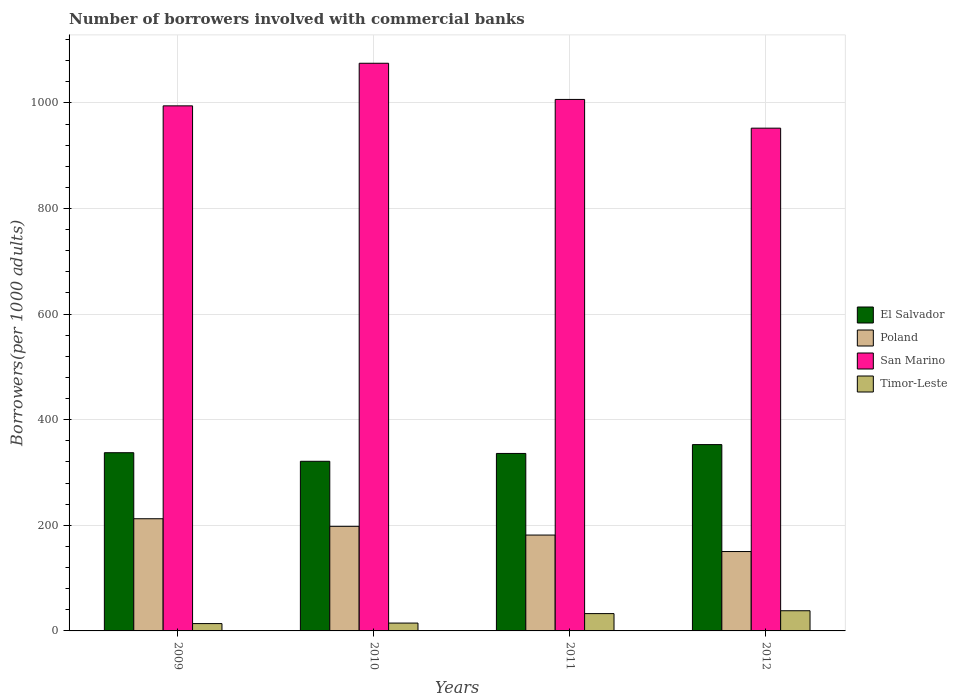What is the label of the 2nd group of bars from the left?
Your answer should be compact. 2010. In how many cases, is the number of bars for a given year not equal to the number of legend labels?
Your answer should be compact. 0. What is the number of borrowers involved with commercial banks in Timor-Leste in 2012?
Your answer should be very brief. 38.21. Across all years, what is the maximum number of borrowers involved with commercial banks in Poland?
Your response must be concise. 212.45. Across all years, what is the minimum number of borrowers involved with commercial banks in El Salvador?
Keep it short and to the point. 321.27. In which year was the number of borrowers involved with commercial banks in San Marino maximum?
Give a very brief answer. 2010. In which year was the number of borrowers involved with commercial banks in San Marino minimum?
Offer a terse response. 2012. What is the total number of borrowers involved with commercial banks in San Marino in the graph?
Offer a terse response. 4028.25. What is the difference between the number of borrowers involved with commercial banks in San Marino in 2011 and that in 2012?
Offer a very short reply. 54.42. What is the difference between the number of borrowers involved with commercial banks in Timor-Leste in 2011 and the number of borrowers involved with commercial banks in San Marino in 2009?
Your answer should be compact. -961.6. What is the average number of borrowers involved with commercial banks in Timor-Leste per year?
Your response must be concise. 24.95. In the year 2011, what is the difference between the number of borrowers involved with commercial banks in El Salvador and number of borrowers involved with commercial banks in Poland?
Your answer should be very brief. 154.57. What is the ratio of the number of borrowers involved with commercial banks in El Salvador in 2010 to that in 2011?
Your response must be concise. 0.96. Is the number of borrowers involved with commercial banks in El Salvador in 2010 less than that in 2011?
Keep it short and to the point. Yes. What is the difference between the highest and the second highest number of borrowers involved with commercial banks in El Salvador?
Your response must be concise. 15.36. What is the difference between the highest and the lowest number of borrowers involved with commercial banks in Timor-Leste?
Offer a very short reply. 24.31. What does the 2nd bar from the left in 2010 represents?
Offer a very short reply. Poland. What does the 4th bar from the right in 2010 represents?
Provide a short and direct response. El Salvador. Is it the case that in every year, the sum of the number of borrowers involved with commercial banks in San Marino and number of borrowers involved with commercial banks in El Salvador is greater than the number of borrowers involved with commercial banks in Poland?
Offer a very short reply. Yes. Are all the bars in the graph horizontal?
Your answer should be compact. No. How many years are there in the graph?
Ensure brevity in your answer.  4. What is the difference between two consecutive major ticks on the Y-axis?
Make the answer very short. 200. Are the values on the major ticks of Y-axis written in scientific E-notation?
Provide a short and direct response. No. Where does the legend appear in the graph?
Your answer should be very brief. Center right. How many legend labels are there?
Ensure brevity in your answer.  4. How are the legend labels stacked?
Your answer should be compact. Vertical. What is the title of the graph?
Your response must be concise. Number of borrowers involved with commercial banks. Does "Seychelles" appear as one of the legend labels in the graph?
Provide a succinct answer. No. What is the label or title of the Y-axis?
Your answer should be very brief. Borrowers(per 1000 adults). What is the Borrowers(per 1000 adults) in El Salvador in 2009?
Make the answer very short. 337.51. What is the Borrowers(per 1000 adults) in Poland in 2009?
Your answer should be compact. 212.45. What is the Borrowers(per 1000 adults) in San Marino in 2009?
Keep it short and to the point. 994.42. What is the Borrowers(per 1000 adults) in Timor-Leste in 2009?
Your answer should be compact. 13.9. What is the Borrowers(per 1000 adults) of El Salvador in 2010?
Give a very brief answer. 321.27. What is the Borrowers(per 1000 adults) of Poland in 2010?
Your answer should be compact. 198.06. What is the Borrowers(per 1000 adults) of San Marino in 2010?
Your answer should be compact. 1075.09. What is the Borrowers(per 1000 adults) of Timor-Leste in 2010?
Provide a succinct answer. 14.87. What is the Borrowers(per 1000 adults) in El Salvador in 2011?
Provide a short and direct response. 336.13. What is the Borrowers(per 1000 adults) in Poland in 2011?
Your response must be concise. 181.56. What is the Borrowers(per 1000 adults) in San Marino in 2011?
Offer a terse response. 1006.58. What is the Borrowers(per 1000 adults) of Timor-Leste in 2011?
Offer a very short reply. 32.81. What is the Borrowers(per 1000 adults) of El Salvador in 2012?
Provide a succinct answer. 352.87. What is the Borrowers(per 1000 adults) in Poland in 2012?
Provide a short and direct response. 150.33. What is the Borrowers(per 1000 adults) of San Marino in 2012?
Give a very brief answer. 952.16. What is the Borrowers(per 1000 adults) of Timor-Leste in 2012?
Provide a succinct answer. 38.21. Across all years, what is the maximum Borrowers(per 1000 adults) in El Salvador?
Make the answer very short. 352.87. Across all years, what is the maximum Borrowers(per 1000 adults) in Poland?
Your answer should be compact. 212.45. Across all years, what is the maximum Borrowers(per 1000 adults) of San Marino?
Provide a short and direct response. 1075.09. Across all years, what is the maximum Borrowers(per 1000 adults) in Timor-Leste?
Provide a succinct answer. 38.21. Across all years, what is the minimum Borrowers(per 1000 adults) in El Salvador?
Ensure brevity in your answer.  321.27. Across all years, what is the minimum Borrowers(per 1000 adults) in Poland?
Provide a short and direct response. 150.33. Across all years, what is the minimum Borrowers(per 1000 adults) in San Marino?
Offer a very short reply. 952.16. Across all years, what is the minimum Borrowers(per 1000 adults) of Timor-Leste?
Offer a terse response. 13.9. What is the total Borrowers(per 1000 adults) of El Salvador in the graph?
Make the answer very short. 1347.78. What is the total Borrowers(per 1000 adults) of Poland in the graph?
Ensure brevity in your answer.  742.4. What is the total Borrowers(per 1000 adults) of San Marino in the graph?
Give a very brief answer. 4028.25. What is the total Borrowers(per 1000 adults) of Timor-Leste in the graph?
Give a very brief answer. 99.79. What is the difference between the Borrowers(per 1000 adults) of El Salvador in 2009 and that in 2010?
Your answer should be compact. 16.24. What is the difference between the Borrowers(per 1000 adults) in Poland in 2009 and that in 2010?
Your answer should be very brief. 14.38. What is the difference between the Borrowers(per 1000 adults) in San Marino in 2009 and that in 2010?
Your response must be concise. -80.68. What is the difference between the Borrowers(per 1000 adults) in Timor-Leste in 2009 and that in 2010?
Your response must be concise. -0.97. What is the difference between the Borrowers(per 1000 adults) in El Salvador in 2009 and that in 2011?
Keep it short and to the point. 1.39. What is the difference between the Borrowers(per 1000 adults) in Poland in 2009 and that in 2011?
Give a very brief answer. 30.89. What is the difference between the Borrowers(per 1000 adults) in San Marino in 2009 and that in 2011?
Keep it short and to the point. -12.17. What is the difference between the Borrowers(per 1000 adults) in Timor-Leste in 2009 and that in 2011?
Keep it short and to the point. -18.91. What is the difference between the Borrowers(per 1000 adults) of El Salvador in 2009 and that in 2012?
Offer a very short reply. -15.36. What is the difference between the Borrowers(per 1000 adults) in Poland in 2009 and that in 2012?
Keep it short and to the point. 62.11. What is the difference between the Borrowers(per 1000 adults) in San Marino in 2009 and that in 2012?
Keep it short and to the point. 42.26. What is the difference between the Borrowers(per 1000 adults) in Timor-Leste in 2009 and that in 2012?
Your answer should be compact. -24.31. What is the difference between the Borrowers(per 1000 adults) in El Salvador in 2010 and that in 2011?
Make the answer very short. -14.86. What is the difference between the Borrowers(per 1000 adults) of Poland in 2010 and that in 2011?
Offer a terse response. 16.51. What is the difference between the Borrowers(per 1000 adults) in San Marino in 2010 and that in 2011?
Offer a very short reply. 68.51. What is the difference between the Borrowers(per 1000 adults) in Timor-Leste in 2010 and that in 2011?
Your answer should be compact. -17.94. What is the difference between the Borrowers(per 1000 adults) of El Salvador in 2010 and that in 2012?
Provide a succinct answer. -31.6. What is the difference between the Borrowers(per 1000 adults) of Poland in 2010 and that in 2012?
Offer a very short reply. 47.73. What is the difference between the Borrowers(per 1000 adults) of San Marino in 2010 and that in 2012?
Give a very brief answer. 122.93. What is the difference between the Borrowers(per 1000 adults) in Timor-Leste in 2010 and that in 2012?
Keep it short and to the point. -23.34. What is the difference between the Borrowers(per 1000 adults) in El Salvador in 2011 and that in 2012?
Your answer should be compact. -16.75. What is the difference between the Borrowers(per 1000 adults) in Poland in 2011 and that in 2012?
Provide a succinct answer. 31.23. What is the difference between the Borrowers(per 1000 adults) in San Marino in 2011 and that in 2012?
Offer a terse response. 54.42. What is the difference between the Borrowers(per 1000 adults) in Timor-Leste in 2011 and that in 2012?
Offer a very short reply. -5.4. What is the difference between the Borrowers(per 1000 adults) of El Salvador in 2009 and the Borrowers(per 1000 adults) of Poland in 2010?
Offer a terse response. 139.45. What is the difference between the Borrowers(per 1000 adults) in El Salvador in 2009 and the Borrowers(per 1000 adults) in San Marino in 2010?
Provide a succinct answer. -737.58. What is the difference between the Borrowers(per 1000 adults) of El Salvador in 2009 and the Borrowers(per 1000 adults) of Timor-Leste in 2010?
Your answer should be compact. 322.64. What is the difference between the Borrowers(per 1000 adults) of Poland in 2009 and the Borrowers(per 1000 adults) of San Marino in 2010?
Ensure brevity in your answer.  -862.64. What is the difference between the Borrowers(per 1000 adults) of Poland in 2009 and the Borrowers(per 1000 adults) of Timor-Leste in 2010?
Offer a very short reply. 197.58. What is the difference between the Borrowers(per 1000 adults) in San Marino in 2009 and the Borrowers(per 1000 adults) in Timor-Leste in 2010?
Offer a terse response. 979.55. What is the difference between the Borrowers(per 1000 adults) of El Salvador in 2009 and the Borrowers(per 1000 adults) of Poland in 2011?
Keep it short and to the point. 155.95. What is the difference between the Borrowers(per 1000 adults) in El Salvador in 2009 and the Borrowers(per 1000 adults) in San Marino in 2011?
Offer a terse response. -669.07. What is the difference between the Borrowers(per 1000 adults) of El Salvador in 2009 and the Borrowers(per 1000 adults) of Timor-Leste in 2011?
Give a very brief answer. 304.7. What is the difference between the Borrowers(per 1000 adults) in Poland in 2009 and the Borrowers(per 1000 adults) in San Marino in 2011?
Offer a terse response. -794.14. What is the difference between the Borrowers(per 1000 adults) in Poland in 2009 and the Borrowers(per 1000 adults) in Timor-Leste in 2011?
Offer a very short reply. 179.64. What is the difference between the Borrowers(per 1000 adults) in San Marino in 2009 and the Borrowers(per 1000 adults) in Timor-Leste in 2011?
Your answer should be very brief. 961.6. What is the difference between the Borrowers(per 1000 adults) of El Salvador in 2009 and the Borrowers(per 1000 adults) of Poland in 2012?
Give a very brief answer. 187.18. What is the difference between the Borrowers(per 1000 adults) of El Salvador in 2009 and the Borrowers(per 1000 adults) of San Marino in 2012?
Provide a short and direct response. -614.65. What is the difference between the Borrowers(per 1000 adults) in El Salvador in 2009 and the Borrowers(per 1000 adults) in Timor-Leste in 2012?
Your answer should be compact. 299.3. What is the difference between the Borrowers(per 1000 adults) of Poland in 2009 and the Borrowers(per 1000 adults) of San Marino in 2012?
Provide a succinct answer. -739.71. What is the difference between the Borrowers(per 1000 adults) of Poland in 2009 and the Borrowers(per 1000 adults) of Timor-Leste in 2012?
Make the answer very short. 174.24. What is the difference between the Borrowers(per 1000 adults) in San Marino in 2009 and the Borrowers(per 1000 adults) in Timor-Leste in 2012?
Your response must be concise. 956.21. What is the difference between the Borrowers(per 1000 adults) in El Salvador in 2010 and the Borrowers(per 1000 adults) in Poland in 2011?
Provide a succinct answer. 139.71. What is the difference between the Borrowers(per 1000 adults) of El Salvador in 2010 and the Borrowers(per 1000 adults) of San Marino in 2011?
Offer a terse response. -685.31. What is the difference between the Borrowers(per 1000 adults) of El Salvador in 2010 and the Borrowers(per 1000 adults) of Timor-Leste in 2011?
Provide a short and direct response. 288.46. What is the difference between the Borrowers(per 1000 adults) of Poland in 2010 and the Borrowers(per 1000 adults) of San Marino in 2011?
Ensure brevity in your answer.  -808.52. What is the difference between the Borrowers(per 1000 adults) of Poland in 2010 and the Borrowers(per 1000 adults) of Timor-Leste in 2011?
Provide a short and direct response. 165.25. What is the difference between the Borrowers(per 1000 adults) in San Marino in 2010 and the Borrowers(per 1000 adults) in Timor-Leste in 2011?
Keep it short and to the point. 1042.28. What is the difference between the Borrowers(per 1000 adults) in El Salvador in 2010 and the Borrowers(per 1000 adults) in Poland in 2012?
Ensure brevity in your answer.  170.93. What is the difference between the Borrowers(per 1000 adults) of El Salvador in 2010 and the Borrowers(per 1000 adults) of San Marino in 2012?
Ensure brevity in your answer.  -630.89. What is the difference between the Borrowers(per 1000 adults) in El Salvador in 2010 and the Borrowers(per 1000 adults) in Timor-Leste in 2012?
Provide a short and direct response. 283.06. What is the difference between the Borrowers(per 1000 adults) of Poland in 2010 and the Borrowers(per 1000 adults) of San Marino in 2012?
Keep it short and to the point. -754.1. What is the difference between the Borrowers(per 1000 adults) of Poland in 2010 and the Borrowers(per 1000 adults) of Timor-Leste in 2012?
Make the answer very short. 159.86. What is the difference between the Borrowers(per 1000 adults) in San Marino in 2010 and the Borrowers(per 1000 adults) in Timor-Leste in 2012?
Your answer should be compact. 1036.88. What is the difference between the Borrowers(per 1000 adults) in El Salvador in 2011 and the Borrowers(per 1000 adults) in Poland in 2012?
Keep it short and to the point. 185.79. What is the difference between the Borrowers(per 1000 adults) of El Salvador in 2011 and the Borrowers(per 1000 adults) of San Marino in 2012?
Keep it short and to the point. -616.03. What is the difference between the Borrowers(per 1000 adults) of El Salvador in 2011 and the Borrowers(per 1000 adults) of Timor-Leste in 2012?
Your answer should be very brief. 297.92. What is the difference between the Borrowers(per 1000 adults) in Poland in 2011 and the Borrowers(per 1000 adults) in San Marino in 2012?
Keep it short and to the point. -770.6. What is the difference between the Borrowers(per 1000 adults) in Poland in 2011 and the Borrowers(per 1000 adults) in Timor-Leste in 2012?
Make the answer very short. 143.35. What is the difference between the Borrowers(per 1000 adults) of San Marino in 2011 and the Borrowers(per 1000 adults) of Timor-Leste in 2012?
Provide a succinct answer. 968.37. What is the average Borrowers(per 1000 adults) of El Salvador per year?
Ensure brevity in your answer.  336.94. What is the average Borrowers(per 1000 adults) in Poland per year?
Your response must be concise. 185.6. What is the average Borrowers(per 1000 adults) of San Marino per year?
Give a very brief answer. 1007.06. What is the average Borrowers(per 1000 adults) in Timor-Leste per year?
Offer a very short reply. 24.95. In the year 2009, what is the difference between the Borrowers(per 1000 adults) in El Salvador and Borrowers(per 1000 adults) in Poland?
Your answer should be very brief. 125.06. In the year 2009, what is the difference between the Borrowers(per 1000 adults) in El Salvador and Borrowers(per 1000 adults) in San Marino?
Your response must be concise. -656.9. In the year 2009, what is the difference between the Borrowers(per 1000 adults) in El Salvador and Borrowers(per 1000 adults) in Timor-Leste?
Make the answer very short. 323.61. In the year 2009, what is the difference between the Borrowers(per 1000 adults) in Poland and Borrowers(per 1000 adults) in San Marino?
Offer a terse response. -781.97. In the year 2009, what is the difference between the Borrowers(per 1000 adults) in Poland and Borrowers(per 1000 adults) in Timor-Leste?
Offer a terse response. 198.54. In the year 2009, what is the difference between the Borrowers(per 1000 adults) in San Marino and Borrowers(per 1000 adults) in Timor-Leste?
Your response must be concise. 980.51. In the year 2010, what is the difference between the Borrowers(per 1000 adults) in El Salvador and Borrowers(per 1000 adults) in Poland?
Provide a short and direct response. 123.2. In the year 2010, what is the difference between the Borrowers(per 1000 adults) in El Salvador and Borrowers(per 1000 adults) in San Marino?
Your response must be concise. -753.82. In the year 2010, what is the difference between the Borrowers(per 1000 adults) of El Salvador and Borrowers(per 1000 adults) of Timor-Leste?
Your response must be concise. 306.4. In the year 2010, what is the difference between the Borrowers(per 1000 adults) in Poland and Borrowers(per 1000 adults) in San Marino?
Offer a very short reply. -877.03. In the year 2010, what is the difference between the Borrowers(per 1000 adults) in Poland and Borrowers(per 1000 adults) in Timor-Leste?
Your answer should be very brief. 183.19. In the year 2010, what is the difference between the Borrowers(per 1000 adults) in San Marino and Borrowers(per 1000 adults) in Timor-Leste?
Give a very brief answer. 1060.22. In the year 2011, what is the difference between the Borrowers(per 1000 adults) in El Salvador and Borrowers(per 1000 adults) in Poland?
Make the answer very short. 154.57. In the year 2011, what is the difference between the Borrowers(per 1000 adults) of El Salvador and Borrowers(per 1000 adults) of San Marino?
Your answer should be compact. -670.46. In the year 2011, what is the difference between the Borrowers(per 1000 adults) in El Salvador and Borrowers(per 1000 adults) in Timor-Leste?
Make the answer very short. 303.32. In the year 2011, what is the difference between the Borrowers(per 1000 adults) of Poland and Borrowers(per 1000 adults) of San Marino?
Offer a terse response. -825.02. In the year 2011, what is the difference between the Borrowers(per 1000 adults) of Poland and Borrowers(per 1000 adults) of Timor-Leste?
Your answer should be very brief. 148.75. In the year 2011, what is the difference between the Borrowers(per 1000 adults) of San Marino and Borrowers(per 1000 adults) of Timor-Leste?
Your answer should be compact. 973.77. In the year 2012, what is the difference between the Borrowers(per 1000 adults) of El Salvador and Borrowers(per 1000 adults) of Poland?
Your response must be concise. 202.54. In the year 2012, what is the difference between the Borrowers(per 1000 adults) in El Salvador and Borrowers(per 1000 adults) in San Marino?
Your response must be concise. -599.29. In the year 2012, what is the difference between the Borrowers(per 1000 adults) of El Salvador and Borrowers(per 1000 adults) of Timor-Leste?
Give a very brief answer. 314.66. In the year 2012, what is the difference between the Borrowers(per 1000 adults) in Poland and Borrowers(per 1000 adults) in San Marino?
Your answer should be very brief. -801.83. In the year 2012, what is the difference between the Borrowers(per 1000 adults) in Poland and Borrowers(per 1000 adults) in Timor-Leste?
Offer a very short reply. 112.13. In the year 2012, what is the difference between the Borrowers(per 1000 adults) in San Marino and Borrowers(per 1000 adults) in Timor-Leste?
Give a very brief answer. 913.95. What is the ratio of the Borrowers(per 1000 adults) in El Salvador in 2009 to that in 2010?
Give a very brief answer. 1.05. What is the ratio of the Borrowers(per 1000 adults) of Poland in 2009 to that in 2010?
Give a very brief answer. 1.07. What is the ratio of the Borrowers(per 1000 adults) in San Marino in 2009 to that in 2010?
Make the answer very short. 0.93. What is the ratio of the Borrowers(per 1000 adults) of Timor-Leste in 2009 to that in 2010?
Your answer should be very brief. 0.94. What is the ratio of the Borrowers(per 1000 adults) in El Salvador in 2009 to that in 2011?
Your answer should be very brief. 1. What is the ratio of the Borrowers(per 1000 adults) of Poland in 2009 to that in 2011?
Offer a very short reply. 1.17. What is the ratio of the Borrowers(per 1000 adults) of San Marino in 2009 to that in 2011?
Keep it short and to the point. 0.99. What is the ratio of the Borrowers(per 1000 adults) in Timor-Leste in 2009 to that in 2011?
Your answer should be very brief. 0.42. What is the ratio of the Borrowers(per 1000 adults) in El Salvador in 2009 to that in 2012?
Provide a succinct answer. 0.96. What is the ratio of the Borrowers(per 1000 adults) in Poland in 2009 to that in 2012?
Offer a terse response. 1.41. What is the ratio of the Borrowers(per 1000 adults) of San Marino in 2009 to that in 2012?
Your response must be concise. 1.04. What is the ratio of the Borrowers(per 1000 adults) in Timor-Leste in 2009 to that in 2012?
Give a very brief answer. 0.36. What is the ratio of the Borrowers(per 1000 adults) in El Salvador in 2010 to that in 2011?
Provide a succinct answer. 0.96. What is the ratio of the Borrowers(per 1000 adults) in Poland in 2010 to that in 2011?
Offer a terse response. 1.09. What is the ratio of the Borrowers(per 1000 adults) of San Marino in 2010 to that in 2011?
Offer a very short reply. 1.07. What is the ratio of the Borrowers(per 1000 adults) in Timor-Leste in 2010 to that in 2011?
Give a very brief answer. 0.45. What is the ratio of the Borrowers(per 1000 adults) of El Salvador in 2010 to that in 2012?
Your answer should be very brief. 0.91. What is the ratio of the Borrowers(per 1000 adults) in Poland in 2010 to that in 2012?
Ensure brevity in your answer.  1.32. What is the ratio of the Borrowers(per 1000 adults) of San Marino in 2010 to that in 2012?
Give a very brief answer. 1.13. What is the ratio of the Borrowers(per 1000 adults) of Timor-Leste in 2010 to that in 2012?
Ensure brevity in your answer.  0.39. What is the ratio of the Borrowers(per 1000 adults) of El Salvador in 2011 to that in 2012?
Make the answer very short. 0.95. What is the ratio of the Borrowers(per 1000 adults) of Poland in 2011 to that in 2012?
Offer a terse response. 1.21. What is the ratio of the Borrowers(per 1000 adults) of San Marino in 2011 to that in 2012?
Provide a short and direct response. 1.06. What is the ratio of the Borrowers(per 1000 adults) of Timor-Leste in 2011 to that in 2012?
Provide a short and direct response. 0.86. What is the difference between the highest and the second highest Borrowers(per 1000 adults) of El Salvador?
Your response must be concise. 15.36. What is the difference between the highest and the second highest Borrowers(per 1000 adults) in Poland?
Keep it short and to the point. 14.38. What is the difference between the highest and the second highest Borrowers(per 1000 adults) in San Marino?
Offer a terse response. 68.51. What is the difference between the highest and the second highest Borrowers(per 1000 adults) of Timor-Leste?
Provide a short and direct response. 5.4. What is the difference between the highest and the lowest Borrowers(per 1000 adults) in El Salvador?
Give a very brief answer. 31.6. What is the difference between the highest and the lowest Borrowers(per 1000 adults) in Poland?
Your answer should be compact. 62.11. What is the difference between the highest and the lowest Borrowers(per 1000 adults) in San Marino?
Your answer should be compact. 122.93. What is the difference between the highest and the lowest Borrowers(per 1000 adults) in Timor-Leste?
Offer a terse response. 24.31. 